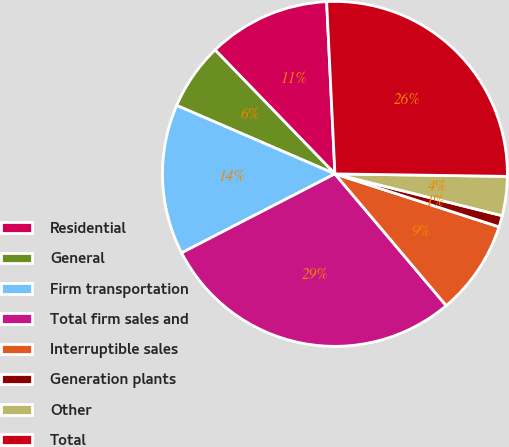Convert chart. <chart><loc_0><loc_0><loc_500><loc_500><pie_chart><fcel>Residential<fcel>General<fcel>Firm transportation<fcel>Total firm sales and<fcel>Interruptible sales<fcel>Generation plants<fcel>Other<fcel>Total<nl><fcel>11.47%<fcel>6.27%<fcel>14.07%<fcel>28.6%<fcel>8.87%<fcel>1.07%<fcel>3.67%<fcel>26.0%<nl></chart> 